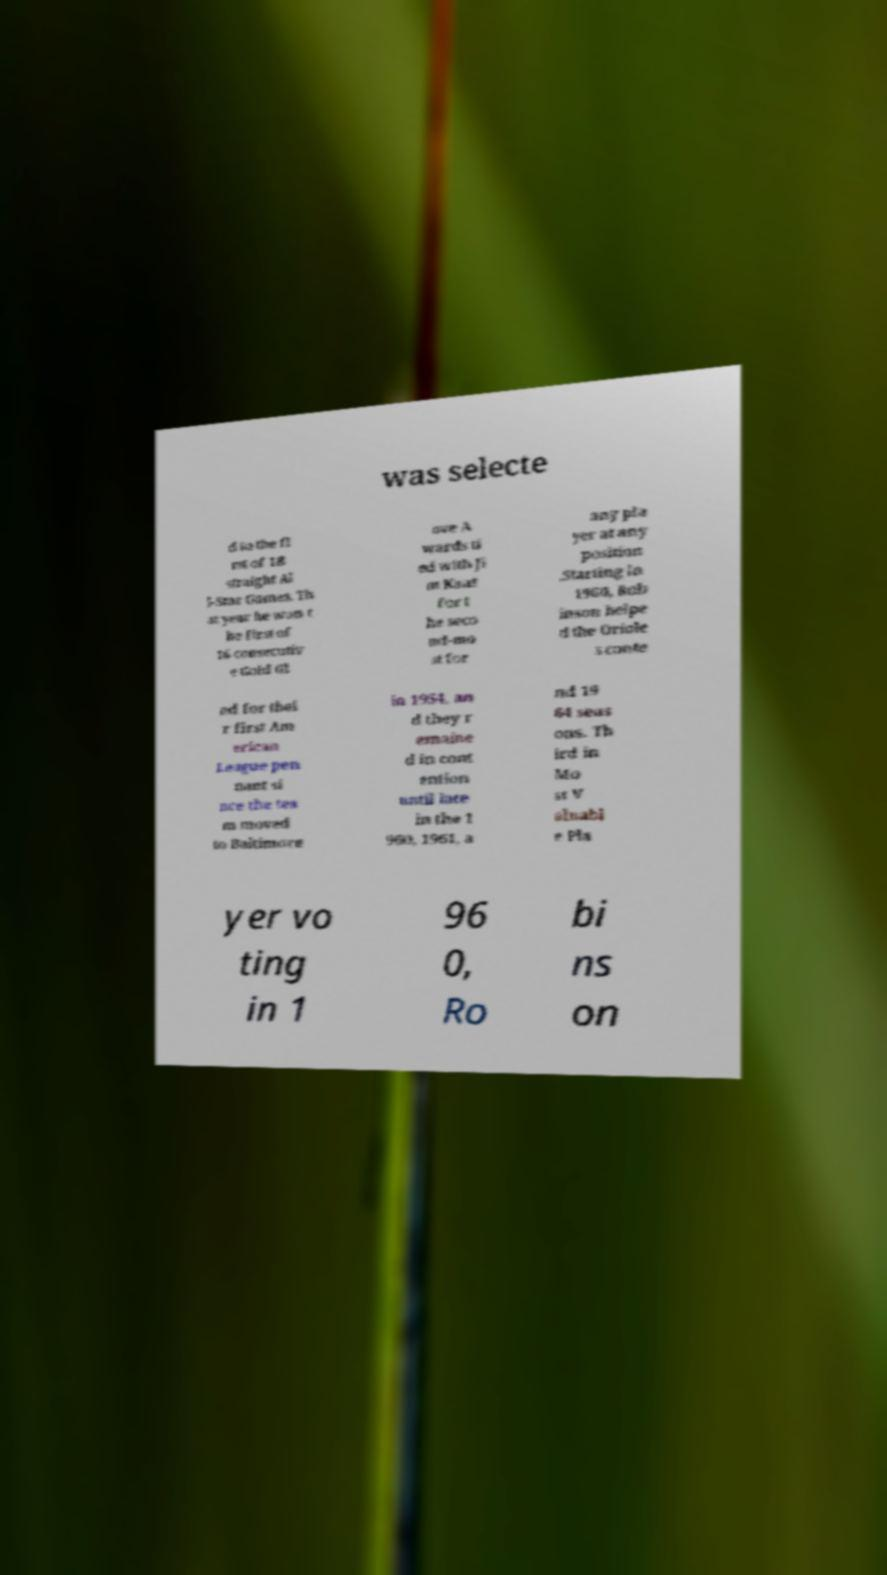Could you assist in decoding the text presented in this image and type it out clearly? was selecte d to the fi rst of 18 straight Al l-Star Games. Th at year he won t he first of 16 consecutiv e Gold Gl ove A wards ti ed with Ji m Kaat for t he seco nd-mo st for any pla yer at any position .Starting in 1960, Rob inson helpe d the Oriole s conte nd for thei r first Am erican League pen nant si nce the tea m moved to Baltimore in 1954, an d they r emaine d in cont ention until late in the 1 960, 1961, a nd 19 64 seas ons. Th ird in Mo st V aluabl e Pla yer vo ting in 1 96 0, Ro bi ns on 